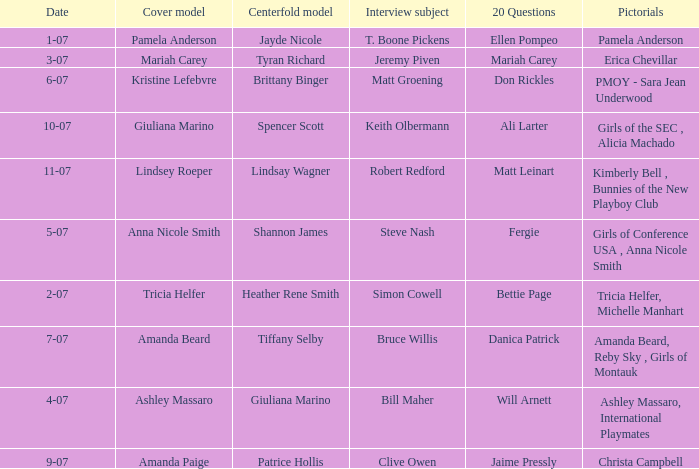Who was the centerfold model when the issue's pictorial was kimberly bell , bunnies of the new playboy club? Lindsay Wagner. 